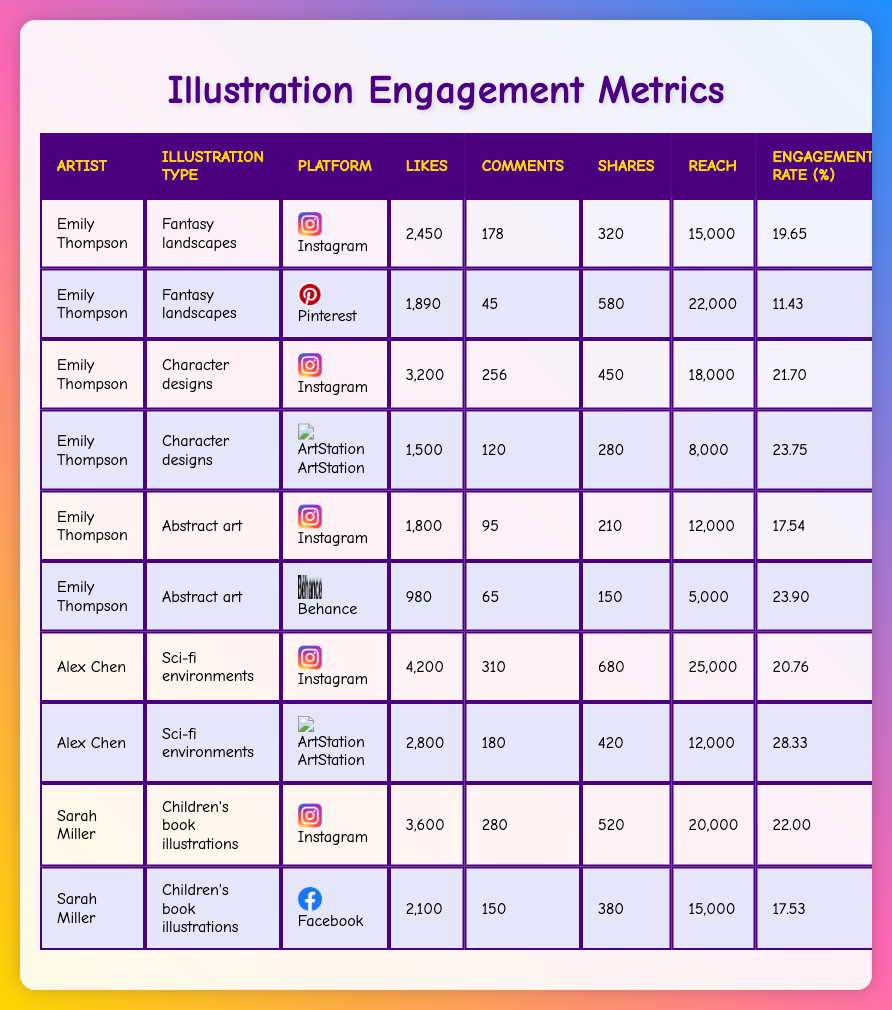What is the highest number of likes for a single illustration? The highest number of likes can be found by scanning through the likes column. In the data, Alex Chen's "Sci-fi environments" illustration on Instagram has 4200 likes, which is the highest compared to all other entries.
Answer: 4200 Which illustration type has the lowest average engagement rate? To find the lowest average engagement rate, we need to calculate the average for each illustration type by summing the engagement rates and dividing by the number of entries. The "Fantasy landscapes" has an average engagement rate of (19.65 + 11.43) / 2 = 15.54, while the other types have higher averages. Therefore, "Fantasy landscapes" has the lowest average engagement rate.
Answer: Fantasy landscapes Did Sarah Miller receive more shares on Instagram for her children’s book illustrations than on Facebook? From the table, Sarah Miller received 520 shares on Instagram and 380 shares on Facebook. Comparing these two values clearly shows that Instagram has more shares.
Answer: Yes What is the total reach for Emily Thompson's illustrations? To calculate the total reach for Emily Thompson's illustrations, we need to sum the reach values from all her entries: 15000 (Fantasy landscapes, Instagram) + 22000 (Fantasy landscapes, Pinterest) + 18000 (Character designs, Instagram) + 8000 (Character designs, ArtStation) + 12000 (Abstract art, Instagram) + 5000 (Abstract art, Behance) = 100000.
Answer: 100000 Which artist has the highest engagement rate on a single platform? We need to examine the engagement rates across all platforms and identify the maximum. Alex Chen's "Sci-fi environments" on ArtStation has an engagement rate of 28.33, which is the highest compared to others.
Answer: Alex Chen What is the percentage increase in likes from Emily Thompson's "Fantasy landscapes" on Instagram to "Character designs" on Instagram? To find the percentage increase, we subtract the likes for "Fantasy landscapes" (2450) from those of "Character designs" (3200), giving us an increase of 750. Then, we divide this increase by the original likes, and multiply by 100 to convert it to a percentage: (750 / 2450) * 100 = 30.61%.
Answer: 30.61% Has Emily Thompson created more illustrations than Alex Chen? By counting the number of entries in the table for both artists, Emily Thompson has 6 entries while Alex Chen has 2. Therefore, Emily Thompson has created more illustrations than Alex Chen.
Answer: Yes What is the total number of comments on Sarah Miller's illustrations? We can find this by adding the comments from her illustrations: 280 (Instagram) + 150 (Facebook) = 430.
Answer: 430 